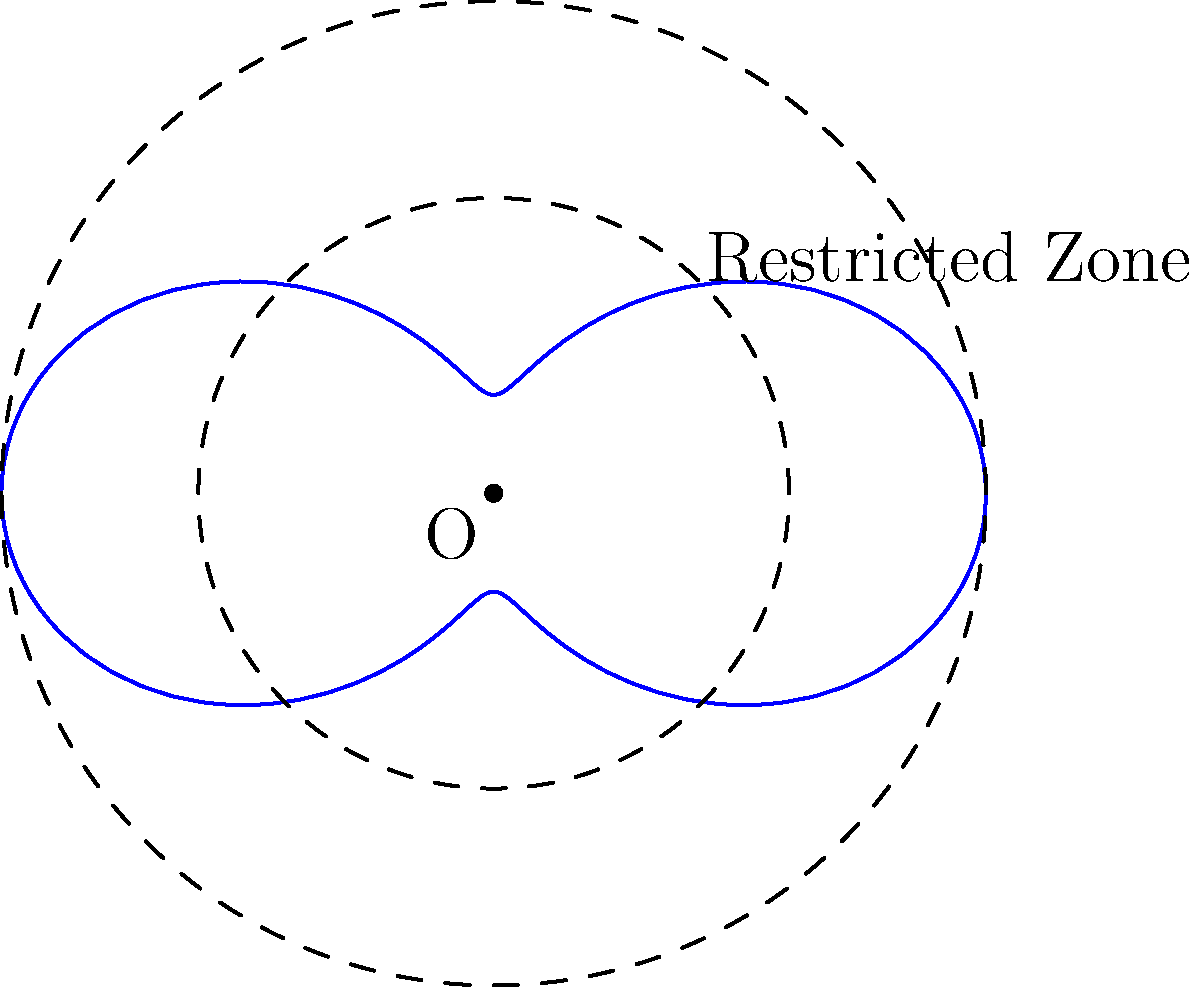In a book about North Korean landmarks, a restricted zone around a sensitive site is described using the polar equation $r = 3 + 2\cos(2\theta)$, where $r$ is measured in kilometers. Calculate the area of this restricted zone in square kilometers. To find the area of the restricted zone, we need to use the formula for the area in polar coordinates:

$$A = \frac{1}{2} \int_{0}^{2\pi} r^2 d\theta$$

Where $r = 3 + 2\cos(2\theta)$

Step 1: Square $r$
$r^2 = (3 + 2\cos(2\theta))^2 = 9 + 12\cos(2\theta) + 4\cos^2(2\theta)$

Step 2: Integrate $r^2$ from 0 to $2\pi$
$$A = \frac{1}{2} \int_{0}^{2\pi} (9 + 12\cos(2\theta) + 4\cos^2(2\theta)) d\theta$$

Step 3: Integrate each term
- $\int_{0}^{2\pi} 9 d\theta = 9\theta |_{0}^{2\pi} = 18\pi$
- $\int_{0}^{2\pi} 12\cos(2\theta) d\theta = 6\sin(2\theta) |_{0}^{2\pi} = 0$
- $\int_{0}^{2\pi} 4\cos^2(2\theta) d\theta = 2\theta + \sin(4\theta)/2 |_{0}^{2\pi} = 4\pi$

Step 4: Sum up the results and multiply by $\frac{1}{2}$
$$A = \frac{1}{2}(18\pi + 0 + 4\pi) = 11\pi$$

Therefore, the area of the restricted zone is $11\pi$ square kilometers.
Answer: $11\pi$ km² 